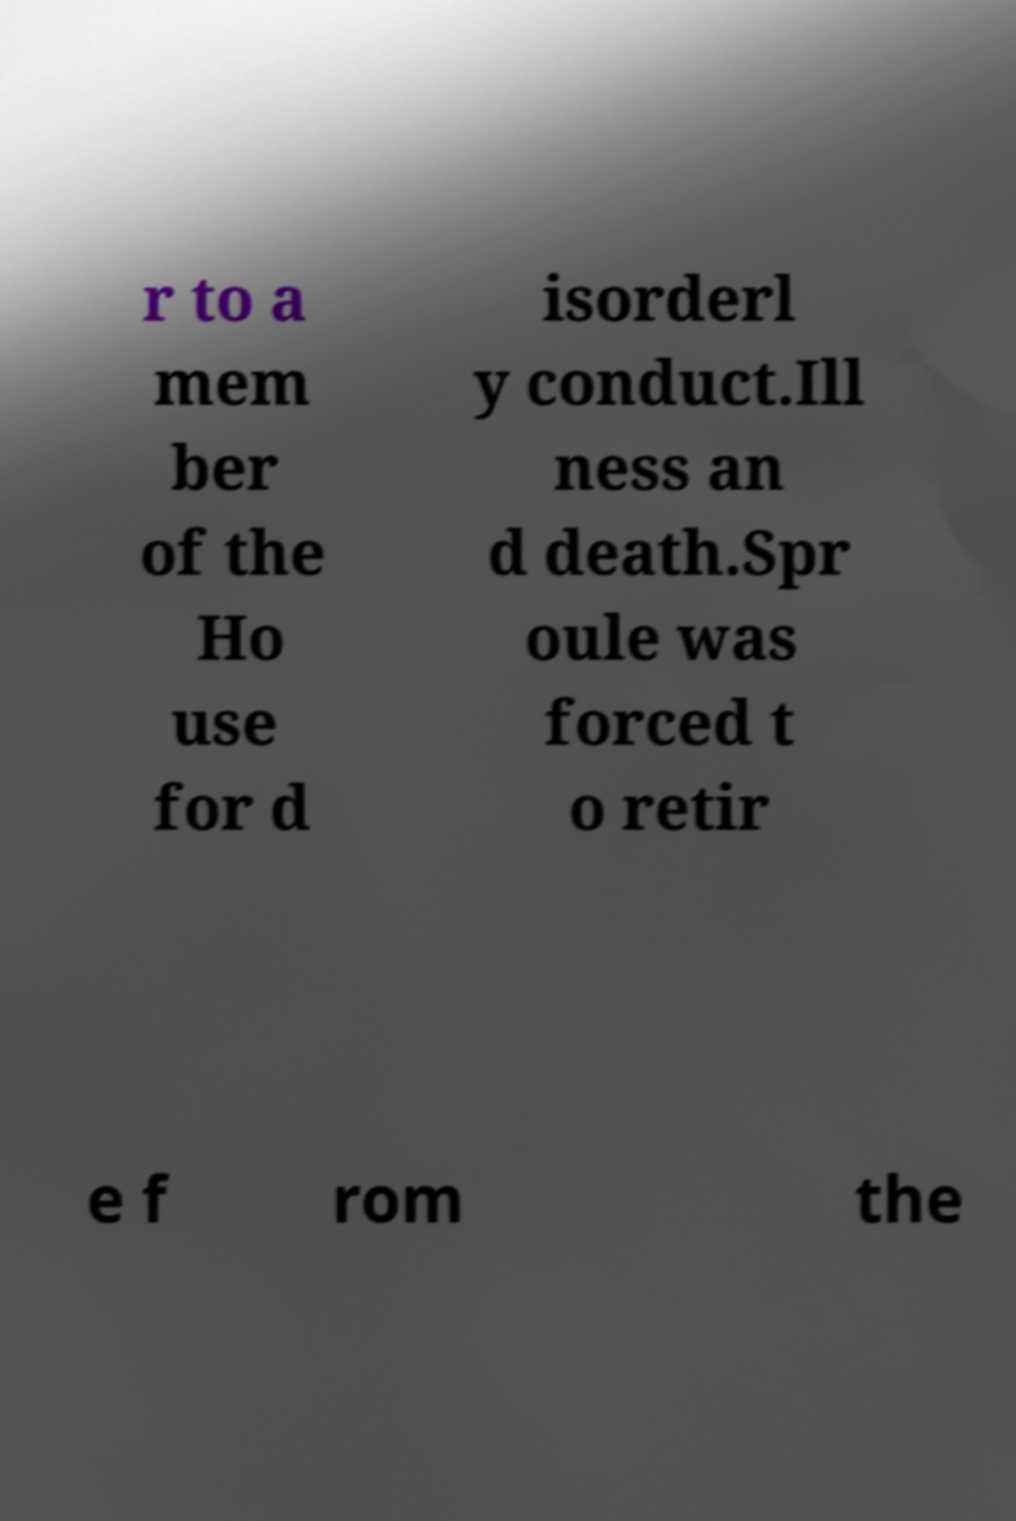Could you assist in decoding the text presented in this image and type it out clearly? r to a mem ber of the Ho use for d isorderl y conduct.Ill ness an d death.Spr oule was forced t o retir e f rom the 